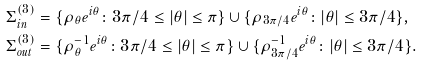<formula> <loc_0><loc_0><loc_500><loc_500>& \Sigma ^ { ( 3 ) } _ { i n } = \{ \rho _ { \theta } e ^ { i \theta } \colon 3 \pi / 4 \leq | \theta | \leq \pi \} \cup \{ \rho _ { 3 \pi / 4 } e ^ { i \theta } \colon | \theta | \leq 3 \pi / 4 \} , \\ & \Sigma ^ { ( 3 ) } _ { o u t } = \{ \rho _ { \theta } ^ { - 1 } e ^ { i \theta } \colon 3 \pi / 4 \leq | \theta | \leq \pi \} \cup \{ \rho _ { 3 \pi / 4 } ^ { - 1 } e ^ { i \theta } \colon | \theta | \leq 3 \pi / 4 \} .</formula> 